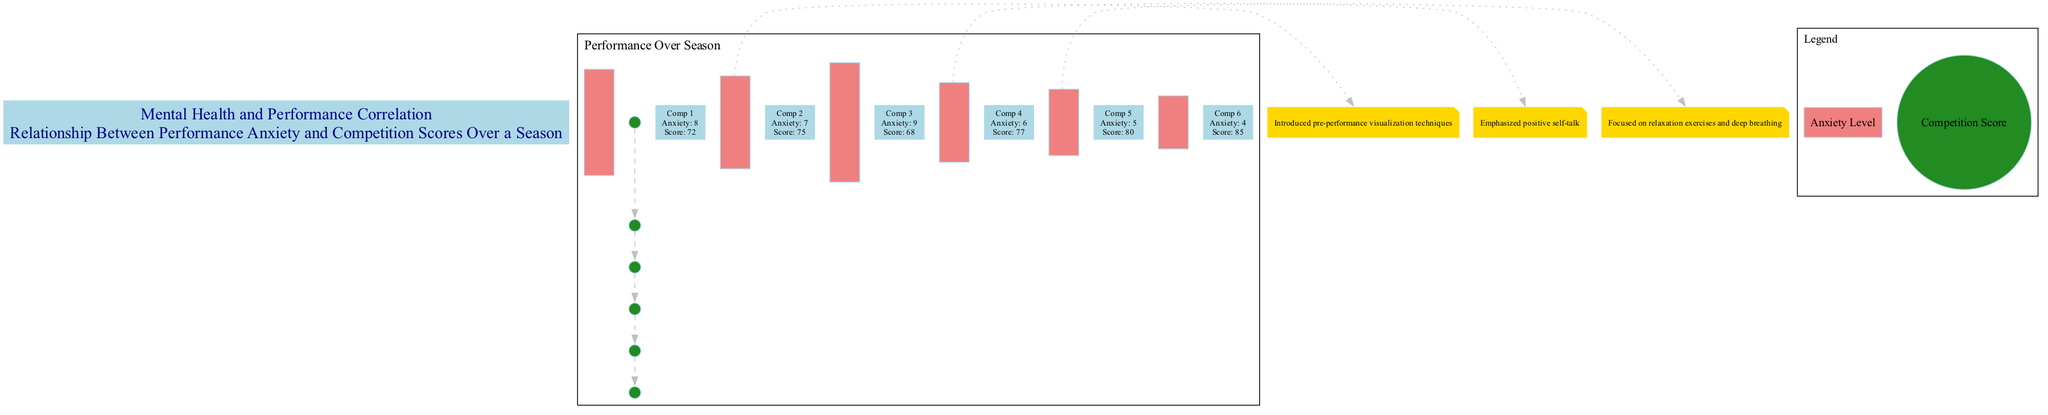What is the anxiety level for competition 3? The diagram shows the bars representing anxiety levels for each competition. For competition 3, the bar indicates an anxiety level of 9.
Answer: 9 What was the competition score for competition 5? The line chart represents competition scores. For competition 5, the line point shows a score of 80.
Answer: 80 Which coaching technique was introduced during competition 2? The annotations connected to competition 2 in the diagram indicate that pre-performance visualization techniques were introduced at that time.
Answer: Pre-performance visualization techniques How many total competitions are shown in the diagram? By counting the competitions labeled from 1 to 6 on the x-axis, there are a total of six competitions represented in the diagram.
Answer: 6 What is the highest competition score achieved in this season? Looking at the line chart, the highest competition score is identified at competition 6, which shows a score of 85.
Answer: 85 What technique was emphasized during competition 4? Referring to the annotation for competition 4 in the diagram, it states that positive self-talk was emphasized during this competition.
Answer: Positive self-talk How did the levels of performance anxiety change from competition 1 to competition 6? Analyzing the bar chart, performance anxiety decreased from 8 in competition 1 to 4 in competition 6, indicating a downward trend in anxiety.
Answer: Decreased At which competition did the coaching focus on relaxation exercises and deep breathing? The diagram's annotation specifies that relaxation exercises and deep breathing were the focus during competition 5.
Answer: Competition 5 What was the anxiety level during competition 4? By looking at the bar graph, it can be seen that the anxiety level during competition 4 is 6.
Answer: 6 